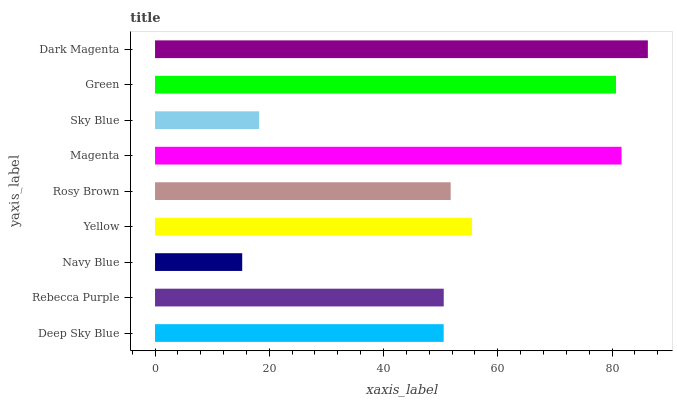Is Navy Blue the minimum?
Answer yes or no. Yes. Is Dark Magenta the maximum?
Answer yes or no. Yes. Is Rebecca Purple the minimum?
Answer yes or no. No. Is Rebecca Purple the maximum?
Answer yes or no. No. Is Rebecca Purple greater than Deep Sky Blue?
Answer yes or no. Yes. Is Deep Sky Blue less than Rebecca Purple?
Answer yes or no. Yes. Is Deep Sky Blue greater than Rebecca Purple?
Answer yes or no. No. Is Rebecca Purple less than Deep Sky Blue?
Answer yes or no. No. Is Rosy Brown the high median?
Answer yes or no. Yes. Is Rosy Brown the low median?
Answer yes or no. Yes. Is Dark Magenta the high median?
Answer yes or no. No. Is Deep Sky Blue the low median?
Answer yes or no. No. 